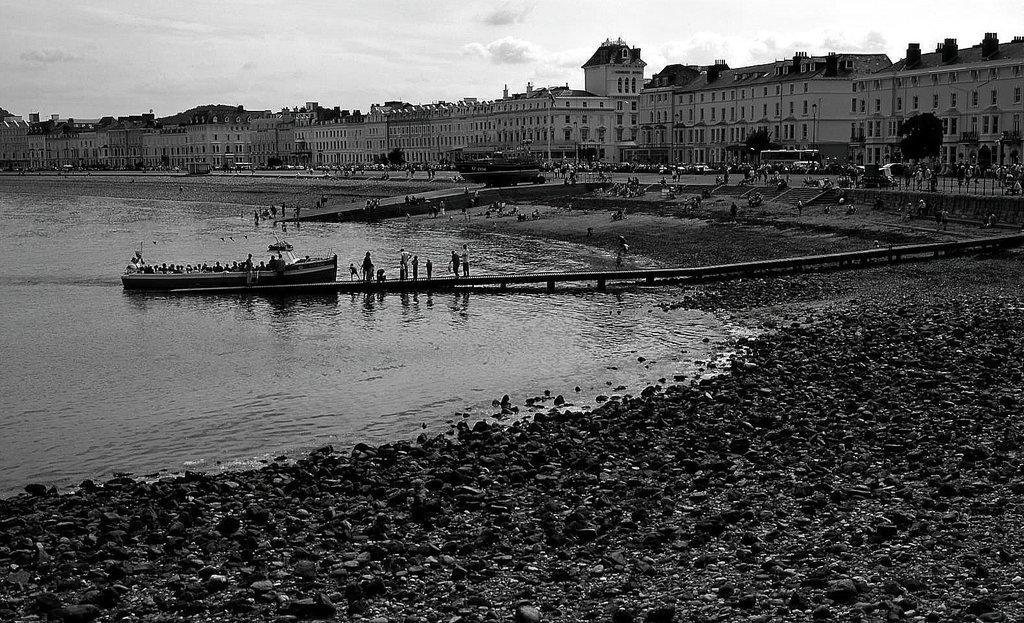What type of natural formation can be seen in the image? There are rocks in the image. What are the people in the image doing? There is a group of people sitting on a boat in the image. Where is the boat located in the image? The boat is on the water in the image. What type of structure can be seen in the image? There is a wooden bridge in the image. What type of man-made structures are visible in the image? There are buildings in the image. What type of vegetation can be seen in the image? There are trees in the image. What part of the natural environment is visible in the image? The sky is visible in the image. Where is the drawer located in the image? There is no drawer present in the image. What type of river can be seen in the image? There is no river present in the image; it features a boat on the water. 